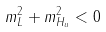Convert formula to latex. <formula><loc_0><loc_0><loc_500><loc_500>m _ { L } ^ { 2 } + m _ { H _ { u } } ^ { 2 } < 0</formula> 